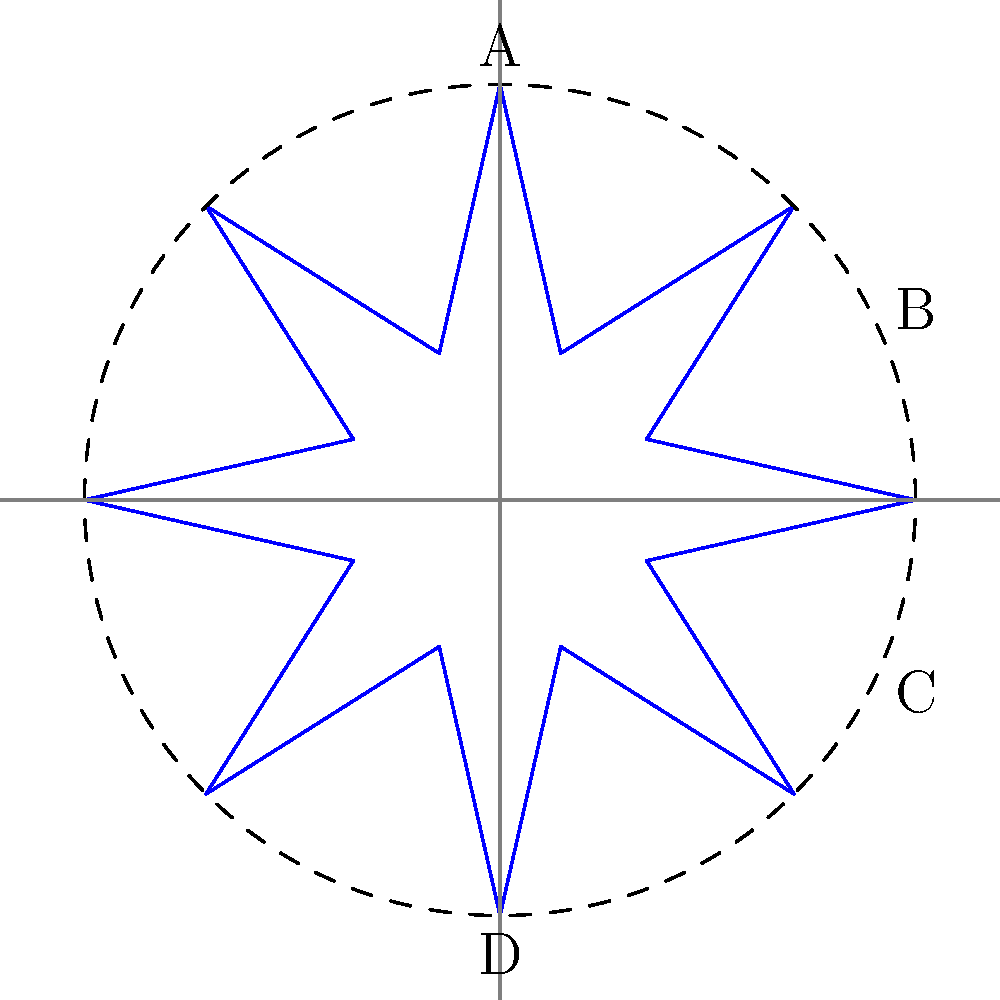In the star design of the Venezuelan flag, consider the angles formed at the center by the points A, B, C, and D. If angle ABC is 45°, what is the measure of angle ACD? Let's approach this step-by-step:

1) First, we need to recognize that the star in the Venezuelan flag is typically an 8-pointed star, which is symmetrical.

2) In a regular 8-pointed star, the center angles between adjacent points are all equal. The total angle at the center is 360°.

3) Since there are 8 points, each center angle measures:
   $$\frac{360°}{8} = 45°$$

4) We're told that angle ABC is 45°. This confirms that we're dealing with a regular 8-pointed star.

5) Now, let's look at angle ACD. It spans 3 of these 45° angles:
   $$3 \times 45° = 135°$$

6) Therefore, angle ACD measures 135°.

This question tests understanding of symmetry, regular polygons, and angle measurements, all within the context of a national symbol, making it relevant to a Venezuelan resident.
Answer: 135° 